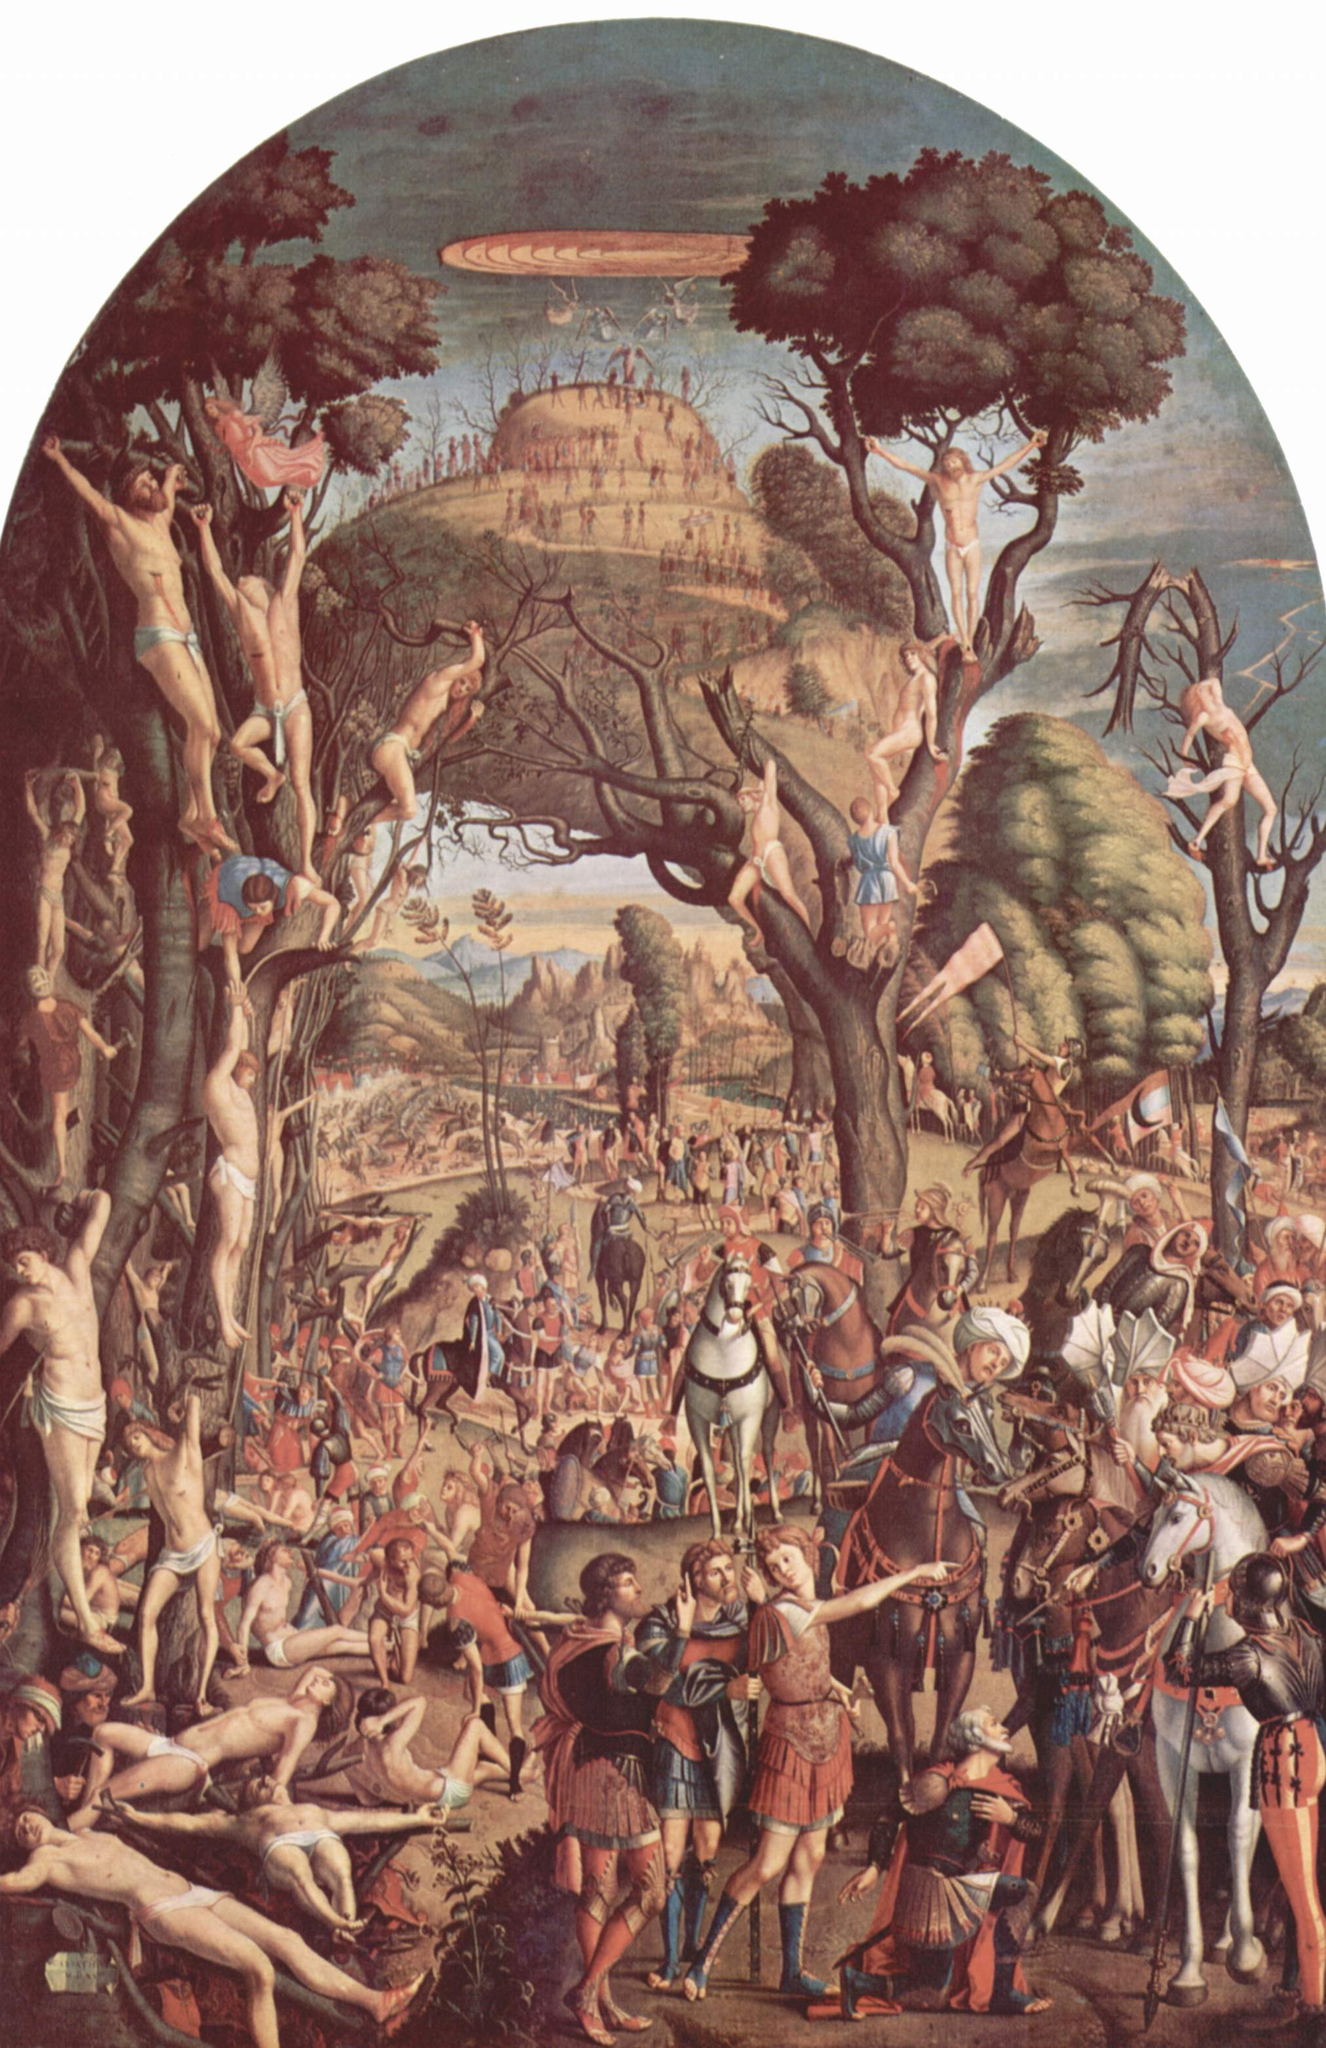Can you explain the symbolism of the tree in this painting? The tree in this painting, with its robust trunk and far-reaching branches filled with nude figures, symbolizes both life and connectivity. In Mannerist art, trees often represent life's complexities and the human condition's intertwined nature. The choice to populate the tree with human figures could suggest humanities' inevitable tie to nature and the shared journey through the vicissitudes of life. Additionally, trees as a central element often point to growth and evolution, echoing the transformative ethos of the Renaissance period. 